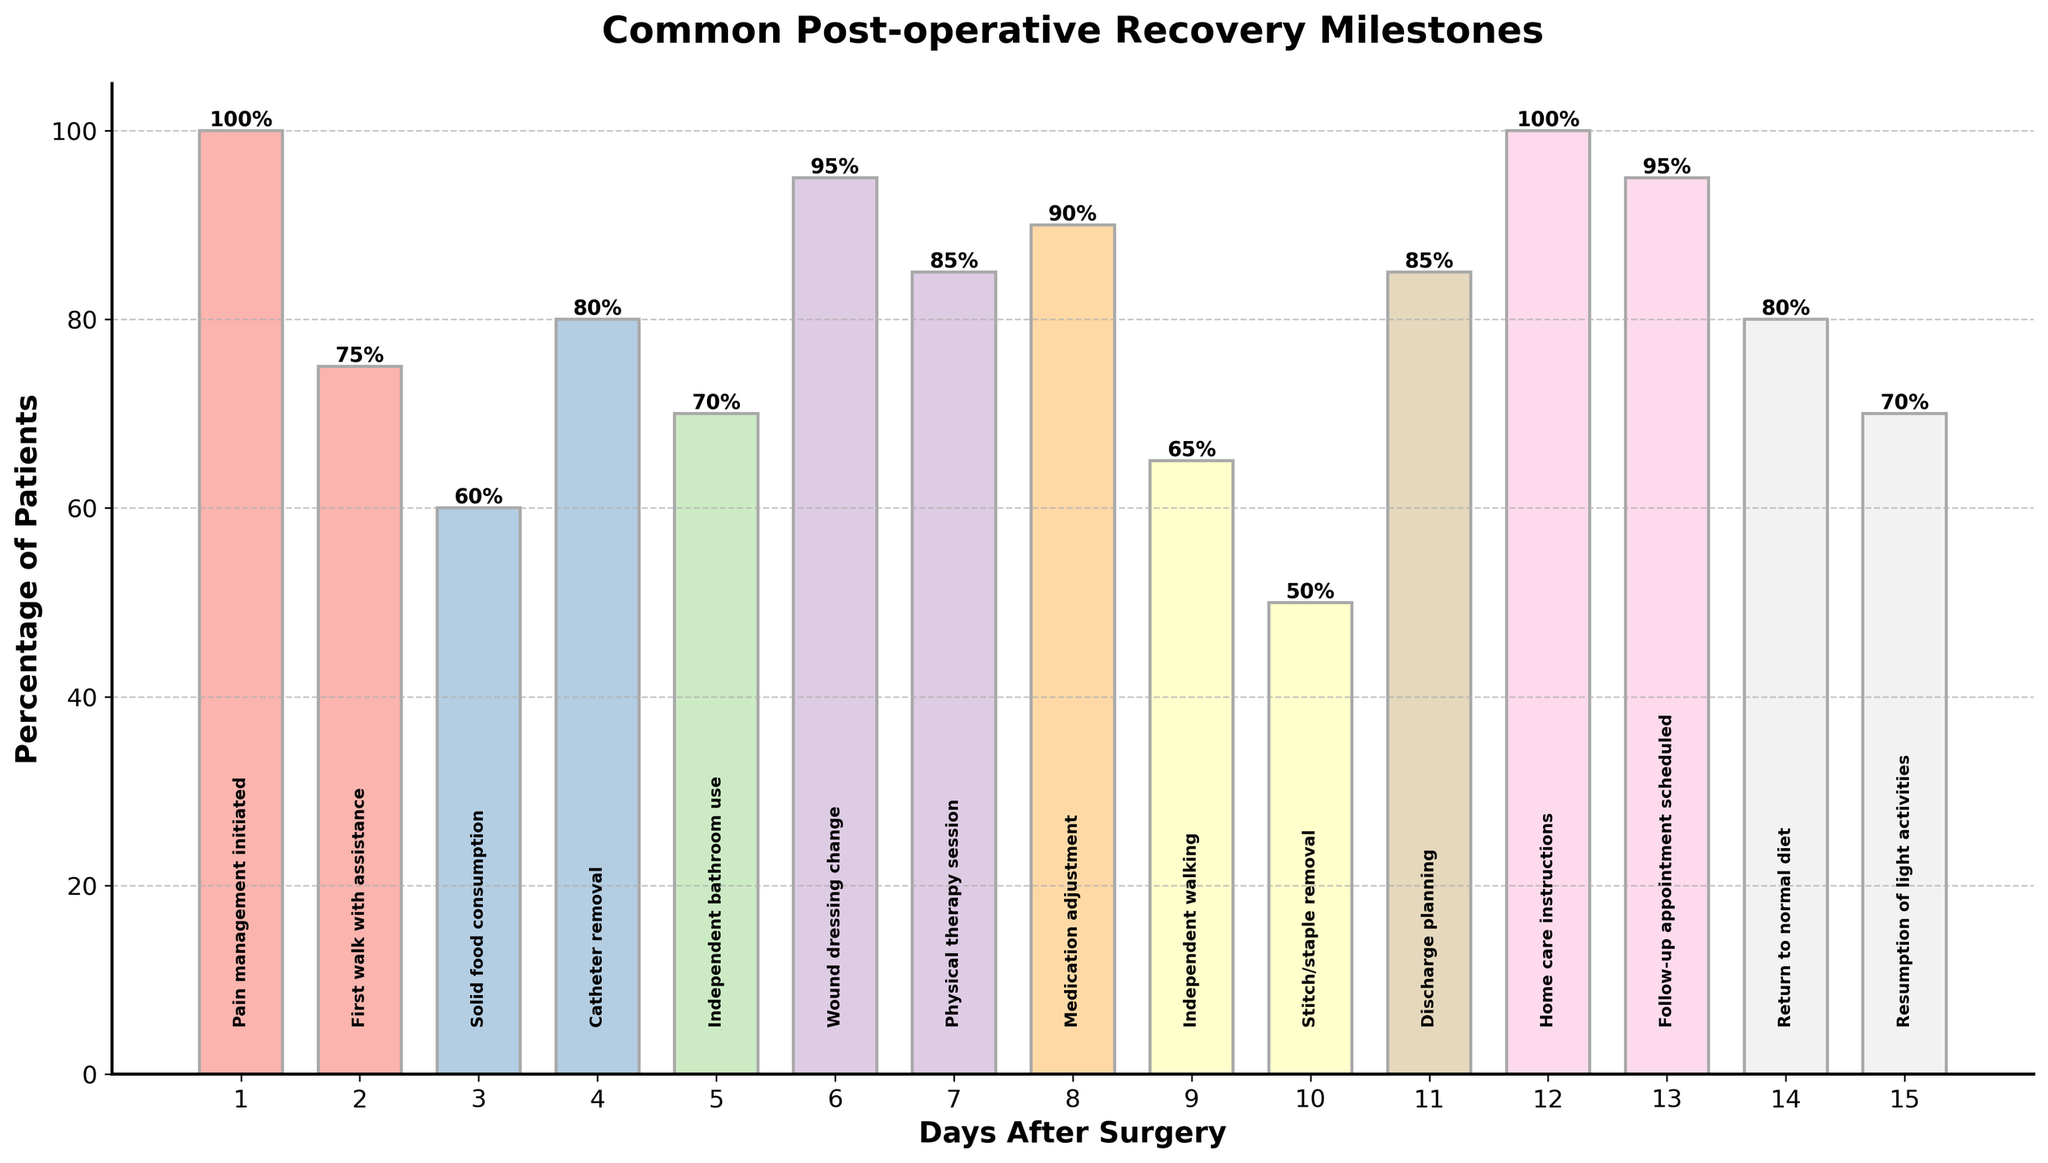Which milestone has the highest percentage of patients reaching it on the same day after surgery? By looking at the height of the bars, the bar for "Pain management initiated" on day 1 reaches the top of the graph, indicating that 100% of patients achieve this milestone. This suggests it has the highest percentage of patients reaching it on the same day.
Answer: Pain management initiated Which milestone has the lowest percentage of patients reaching it, and on which day does this occur? The shortest bar represents the lowest percentage, and from the graph, it is "Stitch/staple removal" with 50% on day 10. The label at the top of this bar also confirms it.
Answer: Stitch/staple removal on day 10 How many milestones are achieved by 80% or more of patients by day 7? Referencing the heights and percentage labels, we identify the bars that reach at least 80%: Pain management initiated (day 1, 100%), Catheter removal (day 4, 80%), Wound dressing change (day 6, 95%), and Home care instructions (day 12, but not within the first 7 days). There are three milestones within the first 7 days.
Answer: 3 Compare the percentage of patients who achieve "First walk with assistance" on day 2 to those who achieve "Independent walking" on day 9. The percentage for "First walk with assistance" on day 2 is 75%, and for "Independent walking" on day 9, it is 65%. Comparing these, 75% is higher than 65%.
Answer: First walk with assistance What is the average percentage of patients who achieve milestones from day 1 to day 3 inclusive? To find the average, sum the percentages for the milestones on days 1, 2, and 3: Pain management initiated (100%), First walk with assistance (75%), and Solid food consumption (60%). The total is 235%. Divide this by the number of days (3) to get the average: 235 / 3 = 78.33%.
Answer: 78.33% Is the percentage of patients who have their "Stitch/staple removal" on day 10 greater than those who "Return to normal diet" by day 14? The percentage of patients for "Stitch/staple removal" on day 10 is 50%. For "Return to normal diet" on day 14, it is 80%. Since 50% is less than 80%, "Stitch/staple removal" is not greater.
Answer: No Which milestone is more commonly achieved, "Independent bathroom use" on day 5 or "Physical therapy session" on day 7? By comparing the heights and percentage labels, "Independent bathroom use" on day 5 is at 70%, and "Physical therapy session" on day 7 is at 85%. Therefore, "Physical therapy session" is more commonly achieved.
Answer: Physical therapy session 